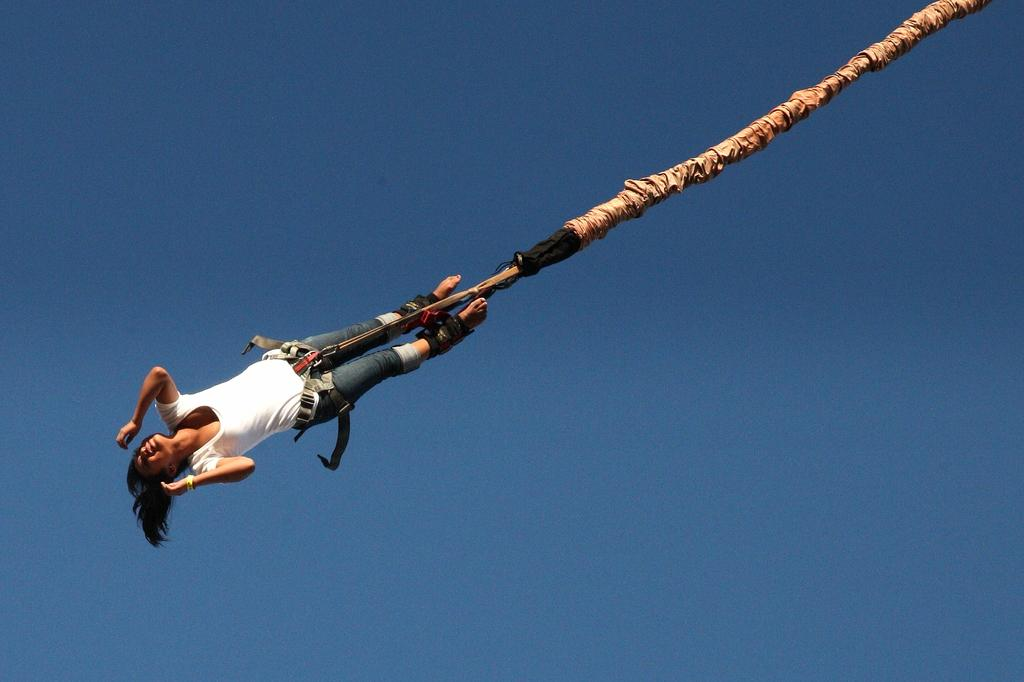Who is the main subject in the image? There is a woman in the image. What is the woman wearing? The woman is wearing a white T-shirt. What is the woman's situation in the image? The woman is tied to a rope. What activity might be taking place in the image? The scene appears to be skydiving. What can be seen in the background of the image? There is a sky visible in the background of the image. What type of cherry can be seen in the woman's hand in the image? There is no cherry present in the image; the woman is tied to a rope and appears to be skydiving. Can you hear the woman's voice in the image? The image is a still photograph, so it does not contain any audible information. 